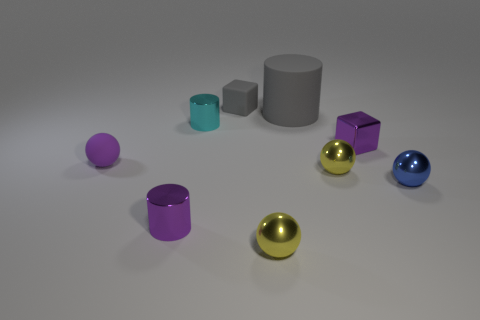Subtract 1 spheres. How many spheres are left? 3 Add 1 green cylinders. How many objects exist? 10 Subtract all cubes. How many objects are left? 7 Add 6 large cylinders. How many large cylinders exist? 7 Subtract 2 yellow balls. How many objects are left? 7 Subtract all big cylinders. Subtract all brown matte things. How many objects are left? 8 Add 8 tiny cylinders. How many tiny cylinders are left? 10 